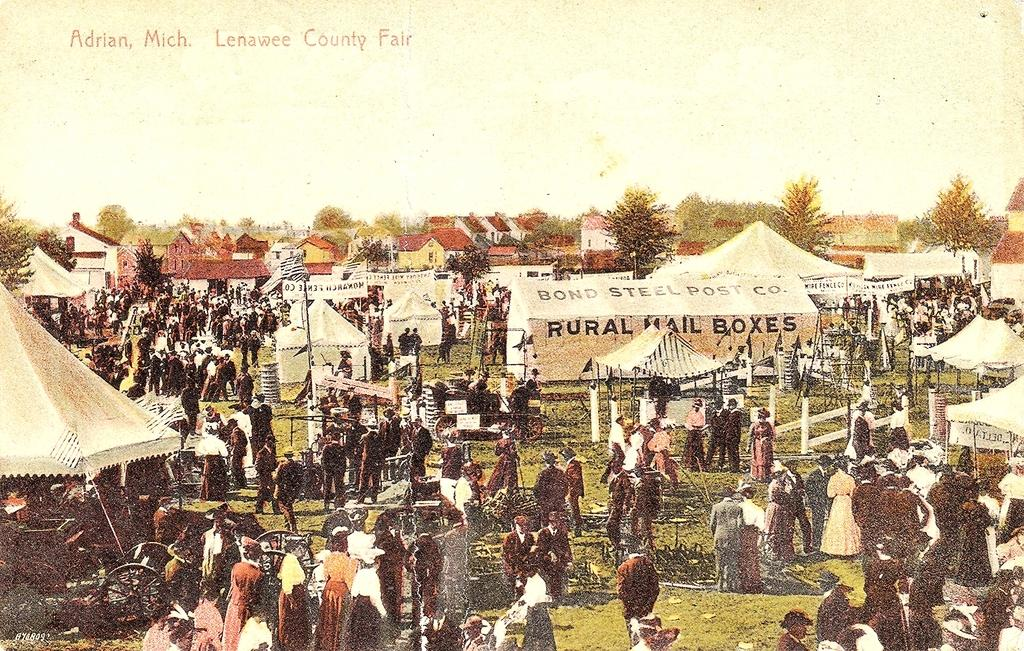Provide a one-sentence caption for the provided image. A vinatge drawing depicts the Lenawee County Fair in Adrian, Michigan where festival attendees stand near tents and a large, rural mail box tent. 